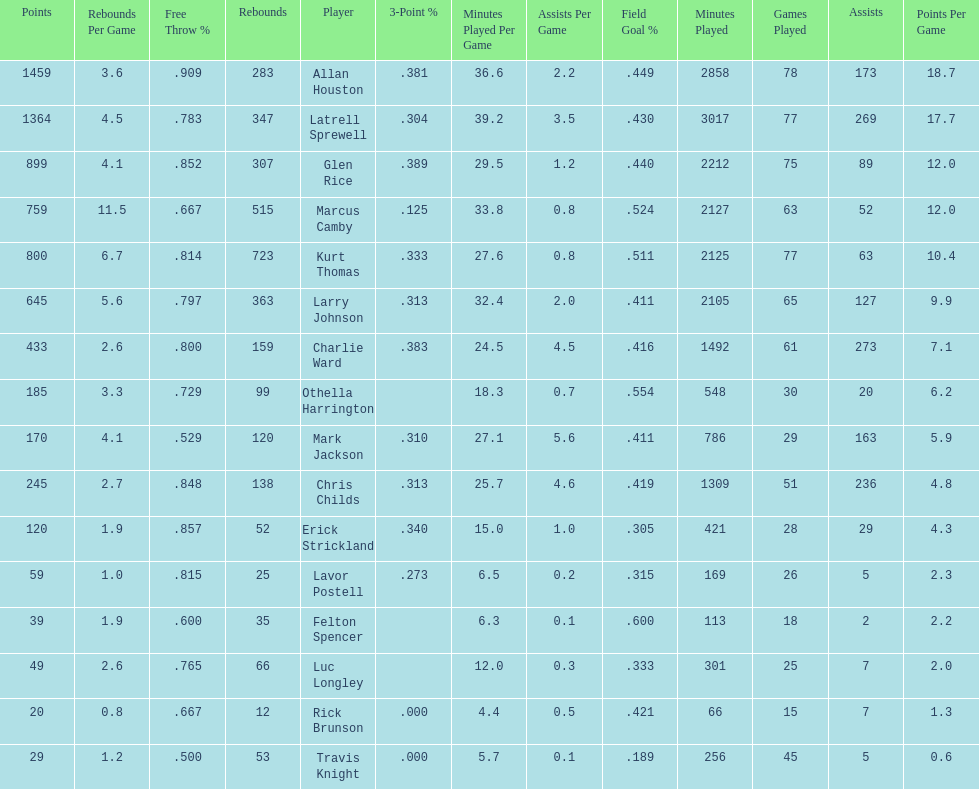Did kurt thomas play more or less than 2126 minutes? Less. 